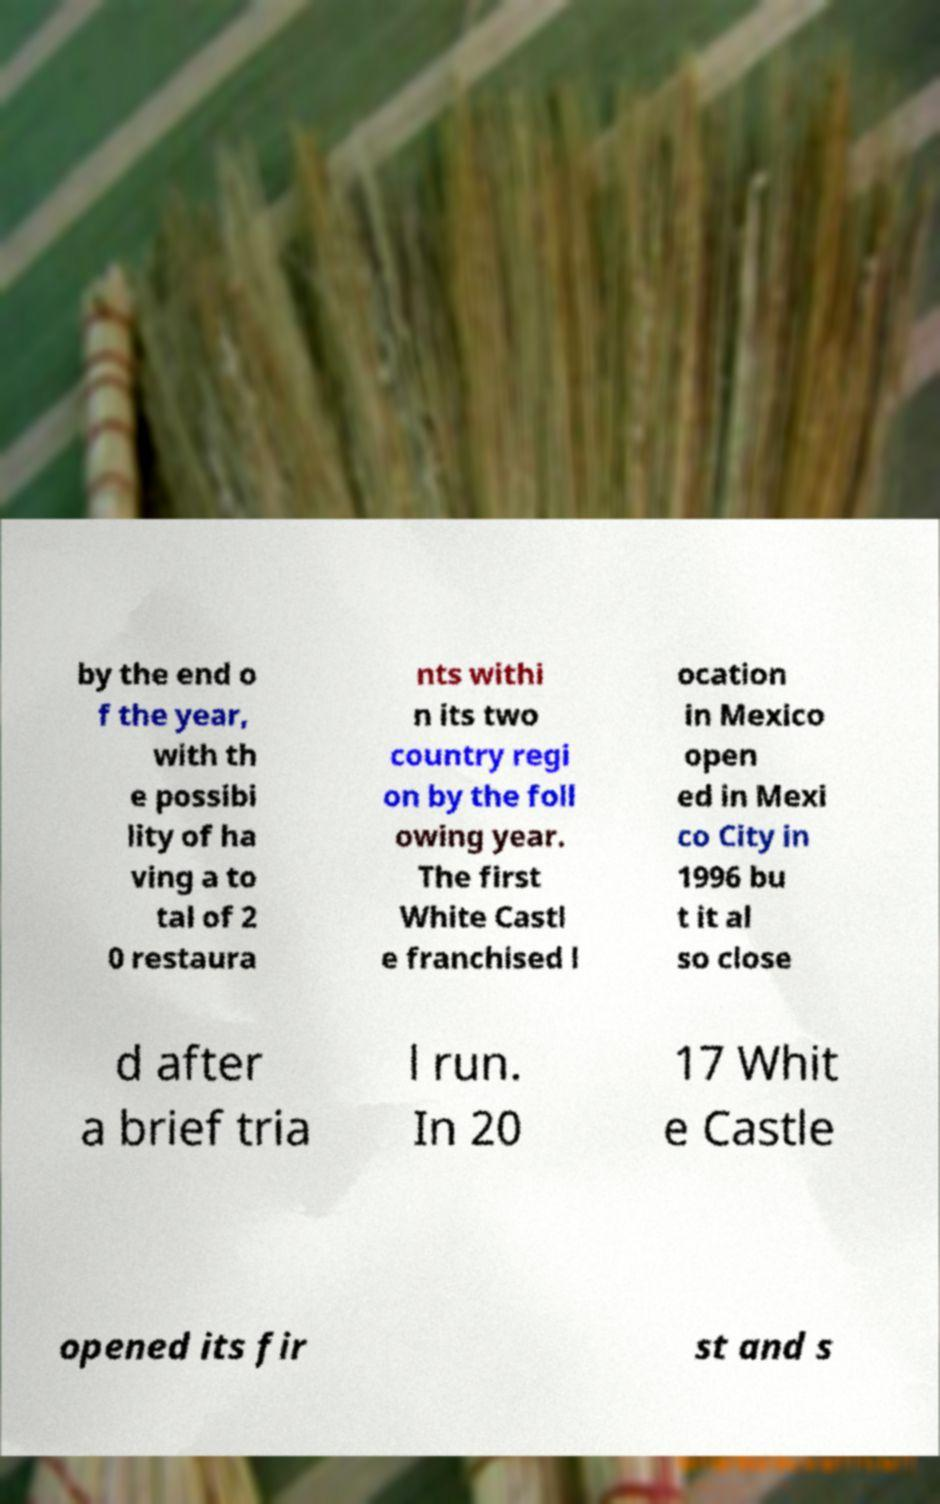What messages or text are displayed in this image? I need them in a readable, typed format. by the end o f the year, with th e possibi lity of ha ving a to tal of 2 0 restaura nts withi n its two country regi on by the foll owing year. The first White Castl e franchised l ocation in Mexico open ed in Mexi co City in 1996 bu t it al so close d after a brief tria l run. In 20 17 Whit e Castle opened its fir st and s 